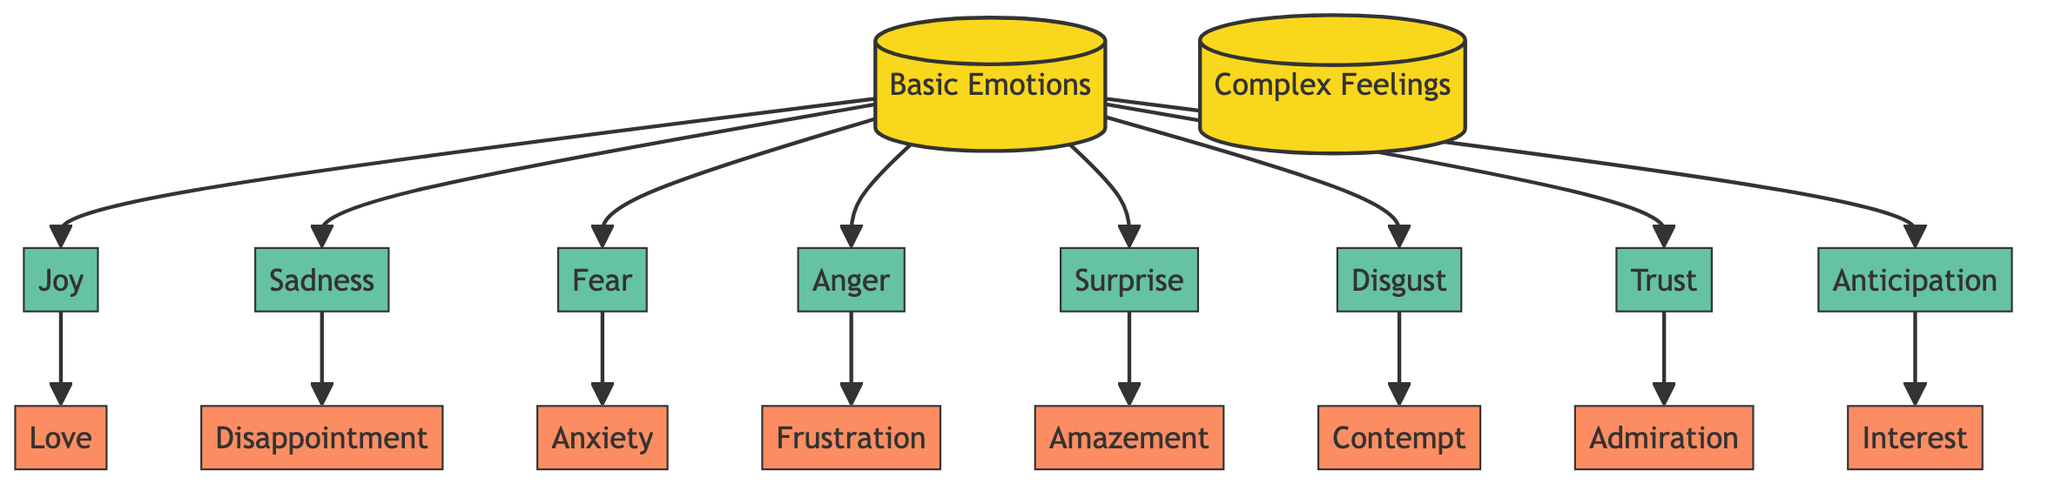What are the basic emotions listed in the diagram? The diagram has a category labeled "Basic Emotions" with the emotions Joy, Sadness, Fear, Anger, Surprise, Disgust, Trust, and Anticipation listed under it.
Answer: Joy, Sadness, Fear, Anger, Surprise, Disgust, Trust, Anticipation How many complex feelings are associated with basic emotions? Under the category "Complex Feelings," there are eight feelings listed: Love, Disappointment, Anxiety, Frustration, Amazement, Contempt, Admiration, and Interest. Thus, there are eight complex feelings.
Answer: 8 Which basic emotion leads to the complex feeling of Love? The diagram shows that Love is directly connected to the basic emotion Joy.
Answer: Joy What is the relationship between Fear and Anxiety in the diagram? Fear is a basic emotion that directly leads to the complex feeling of Anxiety as indicated by the arrow connecting them.
Answer: Anxiety How many edges are there total in the diagram? To find the total number of edges, count the connections: There are 8 edges from Basic Emotions to Complex Feelings and each Basic Emotion has 1 connection, totaling 8 edges.
Answer: 8 Which basic emotion is connected to the feeling of Admiration? Admiration is connected to the basic emotion Trust, as shown by the arrow in the diagram.
Answer: Trust What is the complex feeling associated with Sadness? The diagram indicates that the complex feeling associated with Sadness is Disappointment, as there is a direct link from Sadness to Disappointment.
Answer: Disappointment Which emotion leads to the feeling of Frustration? The emotion of Anger leads directly to the feeling of Frustration as shown in the diagram.
Answer: Anger 